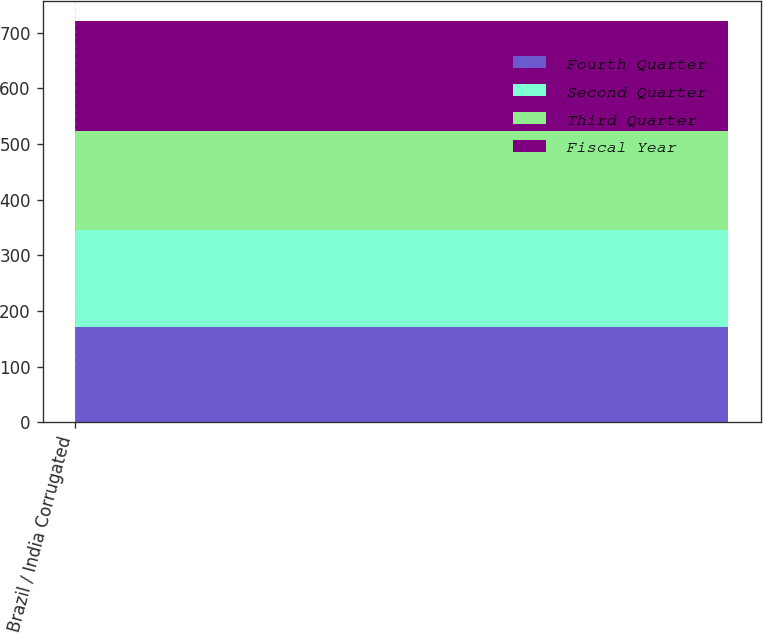<chart> <loc_0><loc_0><loc_500><loc_500><stacked_bar_chart><ecel><fcel>Brazil / India Corrugated<nl><fcel>Fourth Quarter<fcel>170.5<nl><fcel>Second Quarter<fcel>174.6<nl><fcel>Third Quarter<fcel>178.6<nl><fcel>Fiscal Year<fcel>196.7<nl></chart> 